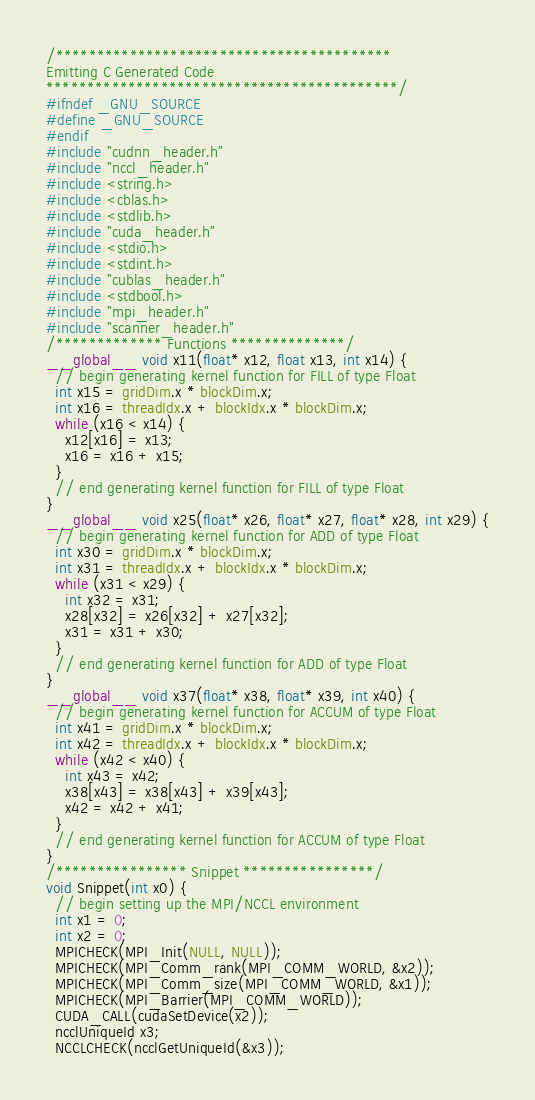<code> <loc_0><loc_0><loc_500><loc_500><_Cuda_>/*****************************************
Emitting C Generated Code
*******************************************/
#ifndef _GNU_SOURCE
#define _GNU_SOURCE
#endif
#include "cudnn_header.h"
#include "nccl_header.h"
#include <string.h>
#include <cblas.h>
#include <stdlib.h>
#include "cuda_header.h"
#include <stdio.h>
#include <stdint.h>
#include "cublas_header.h"
#include <stdbool.h>
#include "mpi_header.h"
#include "scanner_header.h"
/************* Functions **************/
__global__ void x11(float* x12, float x13, int x14) {
  // begin generating kernel function for FILL of type Float
  int x15 = gridDim.x * blockDim.x;
  int x16 = threadIdx.x + blockIdx.x * blockDim.x;
  while (x16 < x14) {
    x12[x16] = x13;
    x16 = x16 + x15;
  }
  // end generating kernel function for FILL of type Float
}
__global__ void x25(float* x26, float* x27, float* x28, int x29) {
  // begin generating kernel function for ADD of type Float
  int x30 = gridDim.x * blockDim.x;
  int x31 = threadIdx.x + blockIdx.x * blockDim.x;
  while (x31 < x29) {
    int x32 = x31;
    x28[x32] = x26[x32] + x27[x32];
    x31 = x31 + x30;
  }
  // end generating kernel function for ADD of type Float
}
__global__ void x37(float* x38, float* x39, int x40) {
  // begin generating kernel function for ACCUM of type Float
  int x41 = gridDim.x * blockDim.x;
  int x42 = threadIdx.x + blockIdx.x * blockDim.x;
  while (x42 < x40) {
    int x43 = x42;
    x38[x43] = x38[x43] + x39[x43];
    x42 = x42 + x41;
  }
  // end generating kernel function for ACCUM of type Float
}
/**************** Snippet ****************/
void Snippet(int x0) {
  // begin setting up the MPI/NCCL environment
  int x1 = 0;
  int x2 = 0;
  MPICHECK(MPI_Init(NULL, NULL));
  MPICHECK(MPI_Comm_rank(MPI_COMM_WORLD, &x2));
  MPICHECK(MPI_Comm_size(MPI_COMM_WORLD, &x1));
  MPICHECK(MPI_Barrier(MPI_COMM_WORLD));
  CUDA_CALL(cudaSetDevice(x2));
  ncclUniqueId x3;
  NCCLCHECK(ncclGetUniqueId(&x3));</code> 